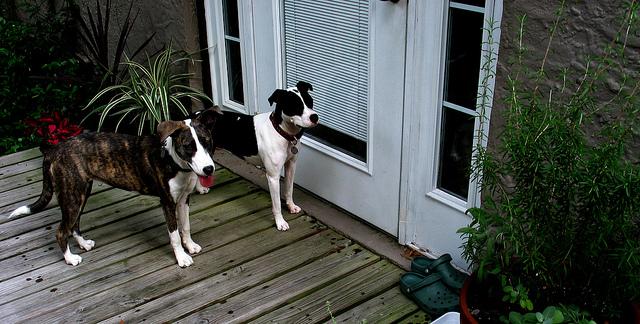What kind of shoes are next to the door?
Give a very brief answer. Crocs. What is covering the window?
Write a very short answer. Blinds. Are these the same type of animals?
Keep it brief. Yes. 